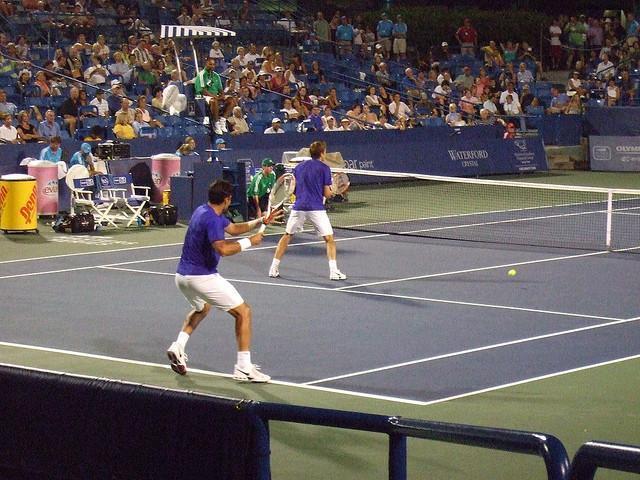How many people are visible?
Give a very brief answer. 3. How many red cars are there?
Give a very brief answer. 0. 